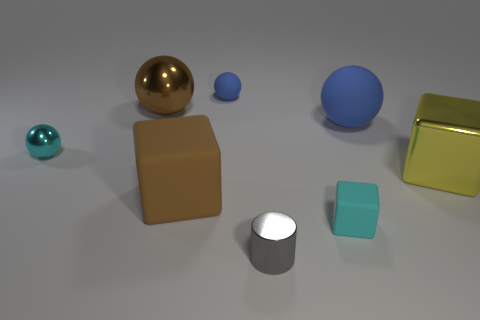Add 1 small shiny objects. How many objects exist? 9 Subtract all large shiny spheres. How many spheres are left? 3 Subtract 3 spheres. How many spheres are left? 1 Subtract all cylinders. How many objects are left? 7 Subtract all cyan balls. How many balls are left? 3 Add 1 yellow things. How many yellow things exist? 2 Subtract 1 blue spheres. How many objects are left? 7 Subtract all purple balls. Subtract all purple cylinders. How many balls are left? 4 Subtract all yellow blocks. How many brown balls are left? 1 Subtract all small blue rubber things. Subtract all brown things. How many objects are left? 5 